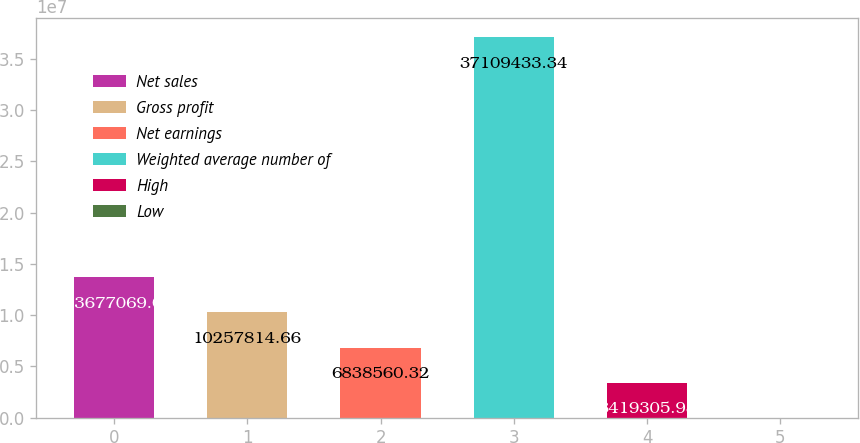<chart> <loc_0><loc_0><loc_500><loc_500><bar_chart><fcel>Net sales<fcel>Gross profit<fcel>Net earnings<fcel>Weighted average number of<fcel>High<fcel>Low<nl><fcel>1.36771e+07<fcel>1.02578e+07<fcel>6.83856e+06<fcel>3.71094e+07<fcel>3.41931e+06<fcel>51.64<nl></chart> 